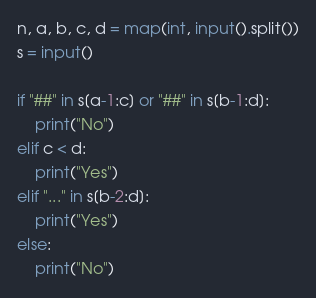<code> <loc_0><loc_0><loc_500><loc_500><_Python_>n, a, b, c, d = map(int, input().split())
s = input()

if "##" in s[a-1:c] or "##" in s[b-1:d]:
    print("No")
elif c < d:
    print("Yes")
elif "..." in s[b-2:d]:
    print("Yes")
else:
    print("No")</code> 